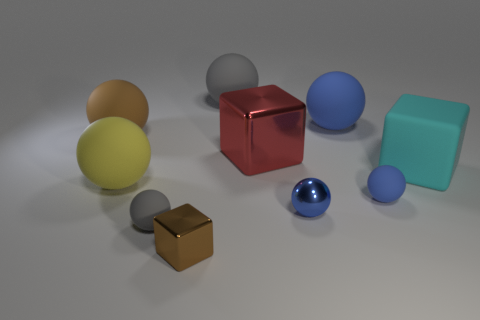Subtract all big gray rubber balls. How many balls are left? 6 Subtract all balls. How many objects are left? 3 Subtract all big brown rubber things. Subtract all big cyan objects. How many objects are left? 8 Add 9 yellow objects. How many yellow objects are left? 10 Add 4 red shiny cubes. How many red shiny cubes exist? 5 Subtract all yellow balls. How many balls are left? 6 Subtract 0 green cubes. How many objects are left? 10 Subtract 4 balls. How many balls are left? 3 Subtract all green blocks. Subtract all yellow spheres. How many blocks are left? 3 Subtract all brown blocks. How many yellow spheres are left? 1 